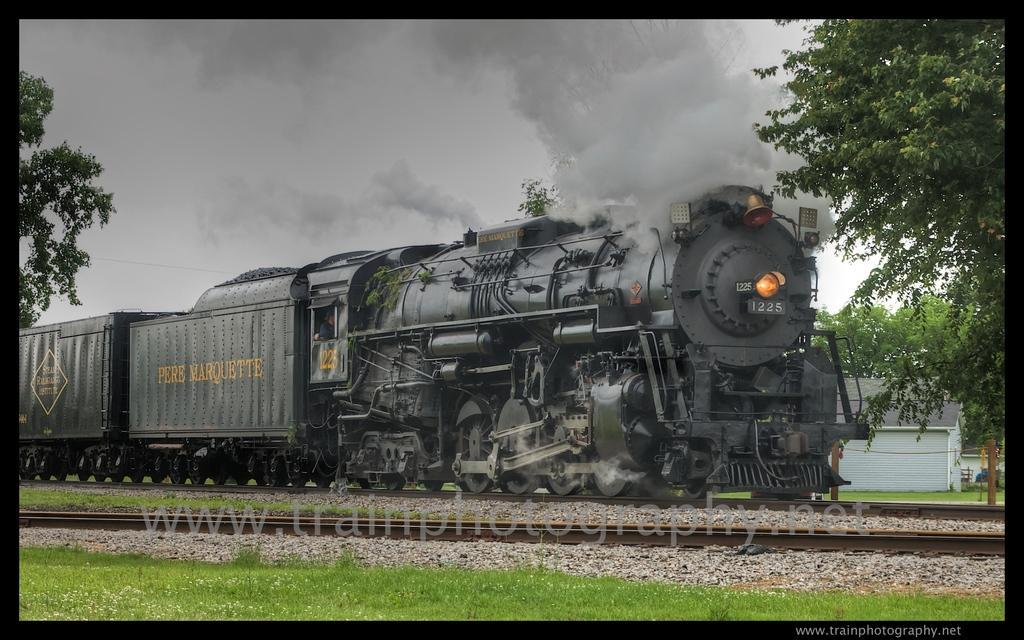Describe this image in one or two sentences. In the center of the picture there are railway tracks and a train. In the foreground there are stones and grass. On the right there are trees and houses. On the left there is a tree. At the top there is smoke. 